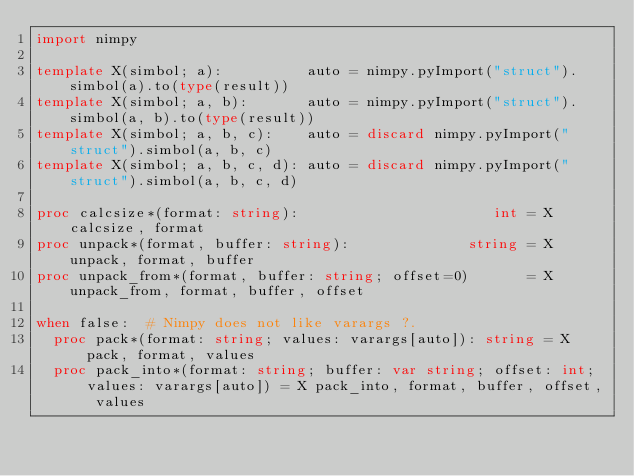<code> <loc_0><loc_0><loc_500><loc_500><_Nim_>import nimpy

template X(simbol; a):          auto = nimpy.pyImport("struct").simbol(a).to(type(result))
template X(simbol; a, b):       auto = nimpy.pyImport("struct").simbol(a, b).to(type(result))
template X(simbol; a, b, c):    auto = discard nimpy.pyImport("struct").simbol(a, b, c)
template X(simbol; a, b, c, d): auto = discard nimpy.pyImport("struct").simbol(a, b, c, d)

proc calcsize*(format: string):                       int = X calcsize, format
proc unpack*(format, buffer: string):              string = X unpack, format, buffer
proc unpack_from*(format, buffer: string; offset=0)       = X unpack_from, format, buffer, offset

when false:  # Nimpy does not like varargs ?.
  proc pack*(format: string; values: varargs[auto]): string = X pack, format, values
  proc pack_into*(format: string; buffer: var string; offset: int; values: varargs[auto]) = X pack_into, format, buffer, offset, values
</code> 